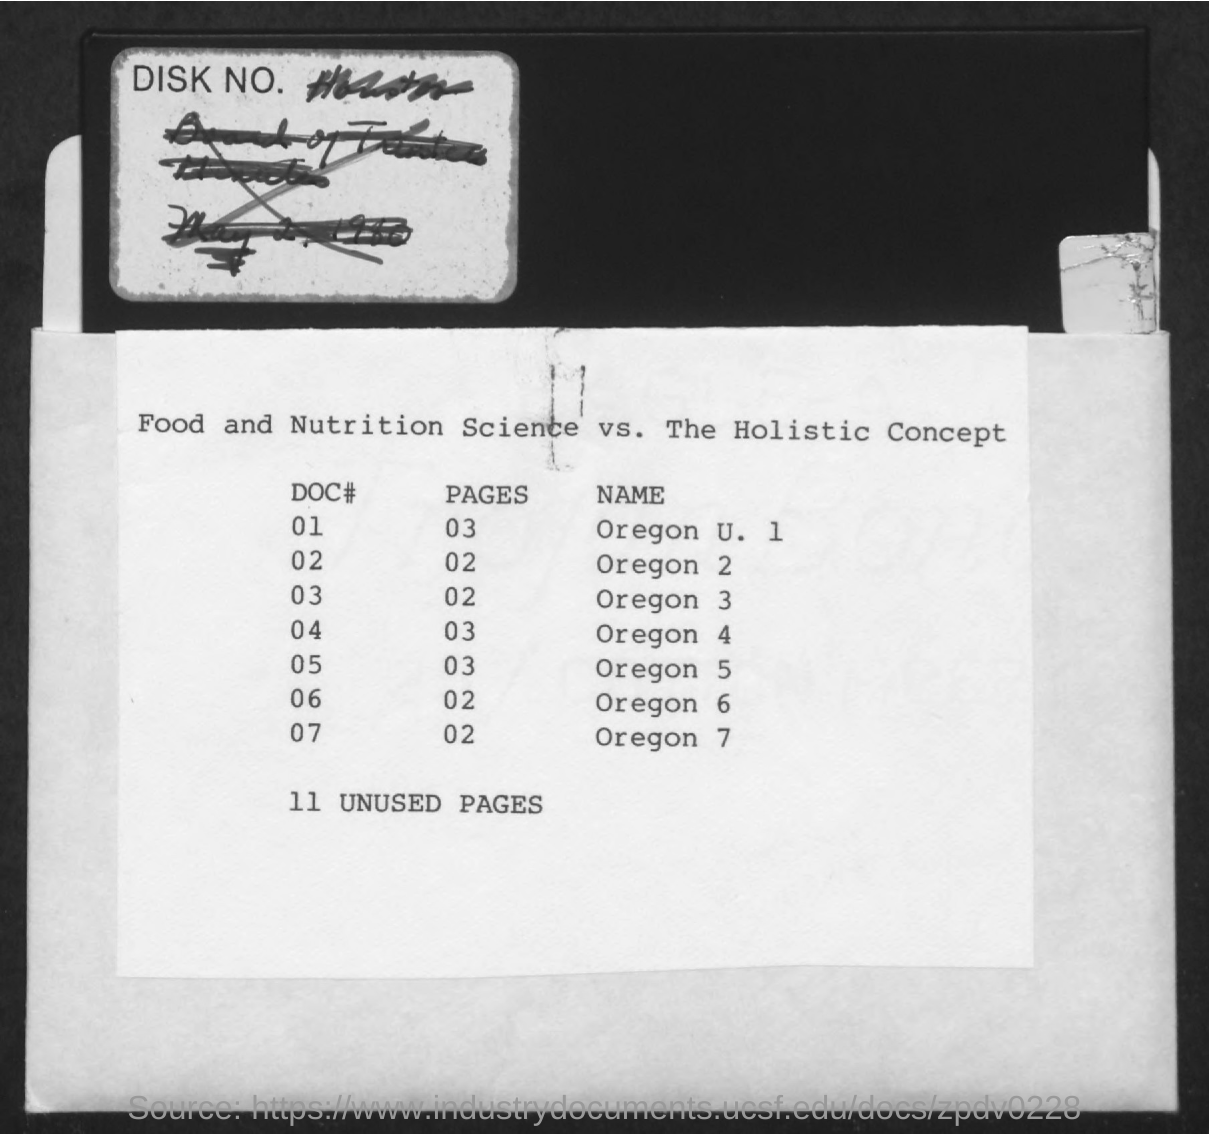Number of unused pages?
Give a very brief answer. 11 unused pages. The name Oregon 7 is in which page?
Your answer should be compact. 02. 